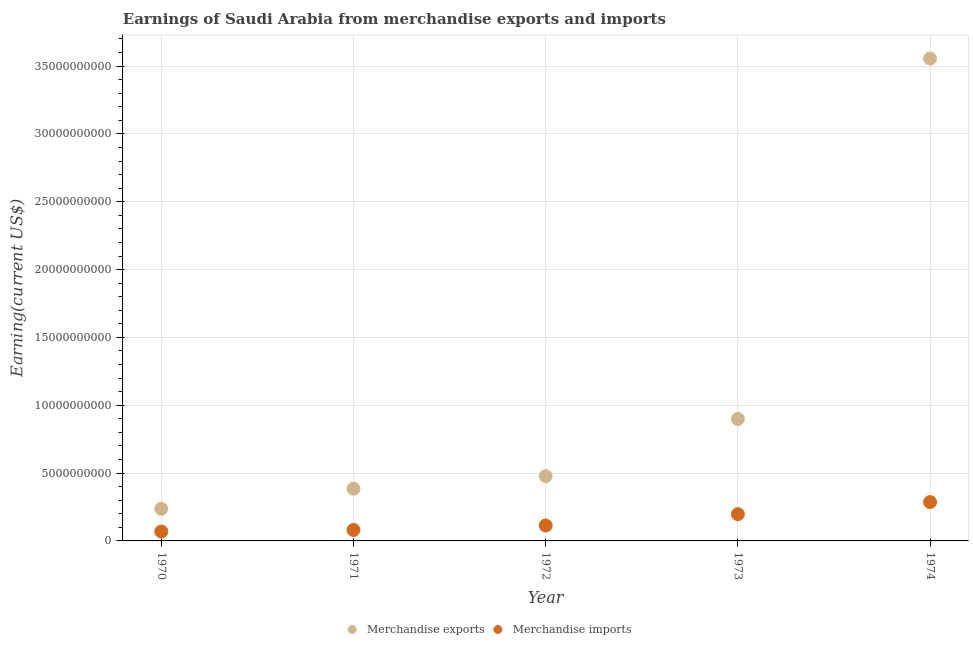How many different coloured dotlines are there?
Your answer should be compact. 2. What is the earnings from merchandise exports in 1973?
Ensure brevity in your answer.  8.99e+09. Across all years, what is the maximum earnings from merchandise imports?
Your answer should be very brief. 2.86e+09. Across all years, what is the minimum earnings from merchandise imports?
Provide a succinct answer. 6.93e+08. In which year was the earnings from merchandise imports maximum?
Provide a succinct answer. 1974. In which year was the earnings from merchandise exports minimum?
Keep it short and to the point. 1970. What is the total earnings from merchandise imports in the graph?
Your answer should be very brief. 7.47e+09. What is the difference between the earnings from merchandise imports in 1970 and that in 1973?
Offer a terse response. -1.28e+09. What is the difference between the earnings from merchandise exports in 1973 and the earnings from merchandise imports in 1971?
Provide a short and direct response. 8.18e+09. What is the average earnings from merchandise exports per year?
Provide a short and direct response. 1.11e+1. In the year 1973, what is the difference between the earnings from merchandise imports and earnings from merchandise exports?
Offer a very short reply. -7.02e+09. What is the ratio of the earnings from merchandise exports in 1970 to that in 1972?
Your answer should be very brief. 0.5. Is the difference between the earnings from merchandise imports in 1970 and 1972 greater than the difference between the earnings from merchandise exports in 1970 and 1972?
Keep it short and to the point. Yes. What is the difference between the highest and the second highest earnings from merchandise exports?
Make the answer very short. 2.66e+1. What is the difference between the highest and the lowest earnings from merchandise imports?
Offer a very short reply. 2.17e+09. Is the sum of the earnings from merchandise imports in 1973 and 1974 greater than the maximum earnings from merchandise exports across all years?
Provide a short and direct response. No. Does the earnings from merchandise imports monotonically increase over the years?
Ensure brevity in your answer.  Yes. Is the earnings from merchandise exports strictly less than the earnings from merchandise imports over the years?
Give a very brief answer. No. How many dotlines are there?
Provide a short and direct response. 2. What is the difference between two consecutive major ticks on the Y-axis?
Ensure brevity in your answer.  5.00e+09. Are the values on the major ticks of Y-axis written in scientific E-notation?
Keep it short and to the point. No. Where does the legend appear in the graph?
Keep it short and to the point. Bottom center. How are the legend labels stacked?
Offer a very short reply. Horizontal. What is the title of the graph?
Your answer should be very brief. Earnings of Saudi Arabia from merchandise exports and imports. Does "Gasoline" appear as one of the legend labels in the graph?
Give a very brief answer. No. What is the label or title of the X-axis?
Keep it short and to the point. Year. What is the label or title of the Y-axis?
Your answer should be very brief. Earning(current US$). What is the Earning(current US$) in Merchandise exports in 1970?
Offer a terse response. 2.37e+09. What is the Earning(current US$) in Merchandise imports in 1970?
Make the answer very short. 6.93e+08. What is the Earning(current US$) of Merchandise exports in 1971?
Your answer should be very brief. 3.85e+09. What is the Earning(current US$) of Merchandise imports in 1971?
Your answer should be very brief. 8.08e+08. What is the Earning(current US$) in Merchandise exports in 1972?
Your answer should be very brief. 4.77e+09. What is the Earning(current US$) in Merchandise imports in 1972?
Provide a succinct answer. 1.14e+09. What is the Earning(current US$) of Merchandise exports in 1973?
Give a very brief answer. 8.99e+09. What is the Earning(current US$) of Merchandise imports in 1973?
Provide a short and direct response. 1.97e+09. What is the Earning(current US$) of Merchandise exports in 1974?
Your answer should be compact. 3.56e+1. What is the Earning(current US$) in Merchandise imports in 1974?
Your answer should be compact. 2.86e+09. Across all years, what is the maximum Earning(current US$) in Merchandise exports?
Your answer should be compact. 3.56e+1. Across all years, what is the maximum Earning(current US$) in Merchandise imports?
Offer a very short reply. 2.86e+09. Across all years, what is the minimum Earning(current US$) of Merchandise exports?
Give a very brief answer. 2.37e+09. Across all years, what is the minimum Earning(current US$) of Merchandise imports?
Your answer should be compact. 6.93e+08. What is the total Earning(current US$) of Merchandise exports in the graph?
Make the answer very short. 5.55e+1. What is the total Earning(current US$) of Merchandise imports in the graph?
Make the answer very short. 7.47e+09. What is the difference between the Earning(current US$) in Merchandise exports in 1970 and that in 1971?
Give a very brief answer. -1.48e+09. What is the difference between the Earning(current US$) of Merchandise imports in 1970 and that in 1971?
Make the answer very short. -1.15e+08. What is the difference between the Earning(current US$) of Merchandise exports in 1970 and that in 1972?
Offer a terse response. -2.40e+09. What is the difference between the Earning(current US$) in Merchandise imports in 1970 and that in 1972?
Ensure brevity in your answer.  -4.43e+08. What is the difference between the Earning(current US$) of Merchandise exports in 1970 and that in 1973?
Give a very brief answer. -6.62e+09. What is the difference between the Earning(current US$) of Merchandise imports in 1970 and that in 1973?
Make the answer very short. -1.28e+09. What is the difference between the Earning(current US$) in Merchandise exports in 1970 and that in 1974?
Your answer should be very brief. -3.32e+1. What is the difference between the Earning(current US$) of Merchandise imports in 1970 and that in 1974?
Ensure brevity in your answer.  -2.17e+09. What is the difference between the Earning(current US$) in Merchandise exports in 1971 and that in 1972?
Offer a very short reply. -9.22e+08. What is the difference between the Earning(current US$) of Merchandise imports in 1971 and that in 1972?
Provide a short and direct response. -3.28e+08. What is the difference between the Earning(current US$) in Merchandise exports in 1971 and that in 1973?
Provide a succinct answer. -5.14e+09. What is the difference between the Earning(current US$) of Merchandise imports in 1971 and that in 1973?
Your response must be concise. -1.16e+09. What is the difference between the Earning(current US$) in Merchandise exports in 1971 and that in 1974?
Ensure brevity in your answer.  -3.17e+1. What is the difference between the Earning(current US$) in Merchandise imports in 1971 and that in 1974?
Give a very brief answer. -2.05e+09. What is the difference between the Earning(current US$) in Merchandise exports in 1972 and that in 1973?
Your answer should be compact. -4.22e+09. What is the difference between the Earning(current US$) of Merchandise imports in 1972 and that in 1973?
Provide a short and direct response. -8.36e+08. What is the difference between the Earning(current US$) in Merchandise exports in 1972 and that in 1974?
Keep it short and to the point. -3.08e+1. What is the difference between the Earning(current US$) of Merchandise imports in 1972 and that in 1974?
Provide a succinct answer. -1.72e+09. What is the difference between the Earning(current US$) of Merchandise exports in 1973 and that in 1974?
Offer a very short reply. -2.66e+1. What is the difference between the Earning(current US$) in Merchandise imports in 1973 and that in 1974?
Your answer should be compact. -8.88e+08. What is the difference between the Earning(current US$) of Merchandise exports in 1970 and the Earning(current US$) of Merchandise imports in 1971?
Offer a terse response. 1.56e+09. What is the difference between the Earning(current US$) in Merchandise exports in 1970 and the Earning(current US$) in Merchandise imports in 1972?
Your response must be concise. 1.24e+09. What is the difference between the Earning(current US$) in Merchandise exports in 1970 and the Earning(current US$) in Merchandise imports in 1973?
Your answer should be very brief. 3.99e+08. What is the difference between the Earning(current US$) in Merchandise exports in 1970 and the Earning(current US$) in Merchandise imports in 1974?
Your answer should be very brief. -4.89e+08. What is the difference between the Earning(current US$) in Merchandise exports in 1971 and the Earning(current US$) in Merchandise imports in 1972?
Your answer should be very brief. 2.71e+09. What is the difference between the Earning(current US$) in Merchandise exports in 1971 and the Earning(current US$) in Merchandise imports in 1973?
Provide a succinct answer. 1.88e+09. What is the difference between the Earning(current US$) in Merchandise exports in 1971 and the Earning(current US$) in Merchandise imports in 1974?
Make the answer very short. 9.91e+08. What is the difference between the Earning(current US$) of Merchandise exports in 1972 and the Earning(current US$) of Merchandise imports in 1973?
Provide a short and direct response. 2.80e+09. What is the difference between the Earning(current US$) in Merchandise exports in 1972 and the Earning(current US$) in Merchandise imports in 1974?
Your response must be concise. 1.91e+09. What is the difference between the Earning(current US$) in Merchandise exports in 1973 and the Earning(current US$) in Merchandise imports in 1974?
Offer a terse response. 6.13e+09. What is the average Earning(current US$) in Merchandise exports per year?
Provide a short and direct response. 1.11e+1. What is the average Earning(current US$) in Merchandise imports per year?
Offer a terse response. 1.49e+09. In the year 1970, what is the difference between the Earning(current US$) in Merchandise exports and Earning(current US$) in Merchandise imports?
Make the answer very short. 1.68e+09. In the year 1971, what is the difference between the Earning(current US$) in Merchandise exports and Earning(current US$) in Merchandise imports?
Your answer should be very brief. 3.04e+09. In the year 1972, what is the difference between the Earning(current US$) of Merchandise exports and Earning(current US$) of Merchandise imports?
Provide a succinct answer. 3.64e+09. In the year 1973, what is the difference between the Earning(current US$) in Merchandise exports and Earning(current US$) in Merchandise imports?
Your answer should be compact. 7.02e+09. In the year 1974, what is the difference between the Earning(current US$) of Merchandise exports and Earning(current US$) of Merchandise imports?
Provide a short and direct response. 3.27e+1. What is the ratio of the Earning(current US$) in Merchandise exports in 1970 to that in 1971?
Offer a very short reply. 0.62. What is the ratio of the Earning(current US$) of Merchandise imports in 1970 to that in 1971?
Provide a succinct answer. 0.86. What is the ratio of the Earning(current US$) of Merchandise exports in 1970 to that in 1972?
Your answer should be compact. 0.5. What is the ratio of the Earning(current US$) in Merchandise imports in 1970 to that in 1972?
Provide a short and direct response. 0.61. What is the ratio of the Earning(current US$) of Merchandise exports in 1970 to that in 1973?
Keep it short and to the point. 0.26. What is the ratio of the Earning(current US$) of Merchandise imports in 1970 to that in 1973?
Offer a very short reply. 0.35. What is the ratio of the Earning(current US$) of Merchandise exports in 1970 to that in 1974?
Make the answer very short. 0.07. What is the ratio of the Earning(current US$) in Merchandise imports in 1970 to that in 1974?
Keep it short and to the point. 0.24. What is the ratio of the Earning(current US$) in Merchandise exports in 1971 to that in 1972?
Offer a terse response. 0.81. What is the ratio of the Earning(current US$) in Merchandise imports in 1971 to that in 1972?
Your response must be concise. 0.71. What is the ratio of the Earning(current US$) of Merchandise exports in 1971 to that in 1973?
Your response must be concise. 0.43. What is the ratio of the Earning(current US$) in Merchandise imports in 1971 to that in 1973?
Offer a terse response. 0.41. What is the ratio of the Earning(current US$) of Merchandise exports in 1971 to that in 1974?
Make the answer very short. 0.11. What is the ratio of the Earning(current US$) of Merchandise imports in 1971 to that in 1974?
Your response must be concise. 0.28. What is the ratio of the Earning(current US$) in Merchandise exports in 1972 to that in 1973?
Your answer should be compact. 0.53. What is the ratio of the Earning(current US$) of Merchandise imports in 1972 to that in 1973?
Ensure brevity in your answer.  0.58. What is the ratio of the Earning(current US$) of Merchandise exports in 1972 to that in 1974?
Your answer should be compact. 0.13. What is the ratio of the Earning(current US$) in Merchandise imports in 1972 to that in 1974?
Keep it short and to the point. 0.4. What is the ratio of the Earning(current US$) in Merchandise exports in 1973 to that in 1974?
Ensure brevity in your answer.  0.25. What is the ratio of the Earning(current US$) of Merchandise imports in 1973 to that in 1974?
Give a very brief answer. 0.69. What is the difference between the highest and the second highest Earning(current US$) of Merchandise exports?
Keep it short and to the point. 2.66e+1. What is the difference between the highest and the second highest Earning(current US$) in Merchandise imports?
Provide a short and direct response. 8.88e+08. What is the difference between the highest and the lowest Earning(current US$) of Merchandise exports?
Offer a very short reply. 3.32e+1. What is the difference between the highest and the lowest Earning(current US$) in Merchandise imports?
Your answer should be very brief. 2.17e+09. 